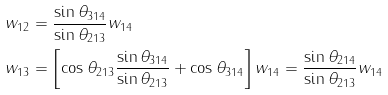<formula> <loc_0><loc_0><loc_500><loc_500>w _ { 1 2 } & = \frac { \sin \theta _ { 3 1 4 } } { \sin \theta _ { 2 1 3 } } w _ { 1 4 } \\ w _ { 1 3 } & = \left [ \cos \theta _ { 2 1 3 } \frac { \sin \theta _ { 3 1 4 } } { \sin \theta _ { 2 1 3 } } + \cos \theta _ { 3 1 4 } \right ] w _ { 1 4 } = \frac { \sin \theta _ { 2 1 4 } } { \sin \theta _ { 2 1 3 } } w _ { 1 4 }</formula> 